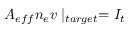Convert formula to latex. <formula><loc_0><loc_0><loc_500><loc_500>A _ { e f f } n _ { e } v | _ { t \arg e t } = I _ { t }</formula> 